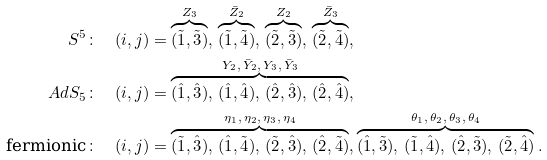Convert formula to latex. <formula><loc_0><loc_0><loc_500><loc_500>S ^ { 5 } & \colon \quad ( i , j ) = \overbrace { ( \tilde { 1 } , \tilde { 3 } ) } ^ { Z _ { 3 } } , \, \overbrace { ( \tilde { 1 } , \tilde { 4 } ) } ^ { \bar { Z } _ { 2 } } , \, \overbrace { ( \tilde { 2 } , \tilde { 3 } ) } ^ { Z _ { 2 } } , \, \overbrace { ( \tilde { 2 } , \tilde { 4 } ) } ^ { \bar { Z } _ { 3 } } , \\ A d S _ { 5 } & \colon \quad ( i , j ) = \overbrace { ( \hat { 1 } , \hat { 3 } ) , \, ( \hat { 1 } , \hat { 4 } ) , \, ( \hat { 2 } , \hat { 3 } ) , \, ( \hat { 2 } , \hat { 4 } ) } ^ { Y _ { 2 } , \, \bar { Y } _ { 2 } , \, Y _ { 3 } , \, \bar { Y } _ { 3 } } , \\ \text {fermionic} & \colon \quad ( i , j ) = \overbrace { ( \tilde { 1 } , \hat { 3 } ) , \, ( \hat { 1 } , \tilde { 4 } ) , \, ( \tilde { 2 } , \hat { 3 } ) , \, ( \hat { 2 } , \tilde { 4 } ) } ^ { \eta _ { 1 } , \, \eta _ { 2 } , \, \eta _ { 3 } , \, \eta _ { 4 } } , \overbrace { ( \hat { 1 } , \tilde { 3 } ) , \, ( \tilde { 1 } , \hat { 4 } ) , \, ( \hat { 2 } , \tilde { 3 } ) , \, ( \tilde { 2 } , \hat { 4 } ) } ^ { \theta _ { 1 } , \, \theta _ { 2 } , \, \theta _ { 3 } , \, \theta _ { 4 } } .</formula> 